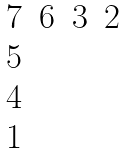<formula> <loc_0><loc_0><loc_500><loc_500>\begin{matrix} 7 & 6 & 3 & 2 \\ 5 & & & \\ 4 & & & \\ 1 & & & \end{matrix}</formula> 